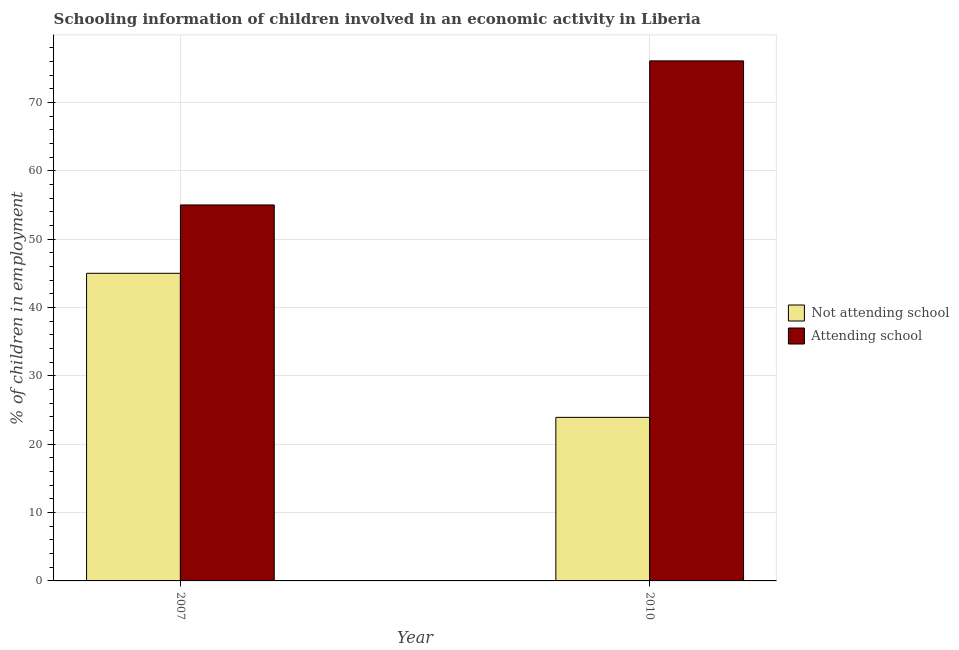How many different coloured bars are there?
Offer a terse response. 2. How many groups of bars are there?
Ensure brevity in your answer.  2. Are the number of bars per tick equal to the number of legend labels?
Offer a terse response. Yes. What is the label of the 2nd group of bars from the left?
Your answer should be very brief. 2010. What is the percentage of employed children who are attending school in 2007?
Offer a terse response. 55. Across all years, what is the maximum percentage of employed children who are attending school?
Your answer should be compact. 76.07. Across all years, what is the minimum percentage of employed children who are not attending school?
Ensure brevity in your answer.  23.93. In which year was the percentage of employed children who are attending school maximum?
Your response must be concise. 2010. In which year was the percentage of employed children who are not attending school minimum?
Give a very brief answer. 2010. What is the total percentage of employed children who are not attending school in the graph?
Provide a short and direct response. 68.93. What is the difference between the percentage of employed children who are attending school in 2007 and that in 2010?
Your answer should be compact. -21.07. What is the difference between the percentage of employed children who are attending school in 2010 and the percentage of employed children who are not attending school in 2007?
Your answer should be very brief. 21.07. What is the average percentage of employed children who are not attending school per year?
Provide a short and direct response. 34.46. In how many years, is the percentage of employed children who are not attending school greater than 58 %?
Give a very brief answer. 0. What is the ratio of the percentage of employed children who are attending school in 2007 to that in 2010?
Keep it short and to the point. 0.72. Is the percentage of employed children who are not attending school in 2007 less than that in 2010?
Your answer should be compact. No. In how many years, is the percentage of employed children who are not attending school greater than the average percentage of employed children who are not attending school taken over all years?
Your answer should be very brief. 1. What does the 2nd bar from the left in 2007 represents?
Offer a terse response. Attending school. What does the 1st bar from the right in 2007 represents?
Your response must be concise. Attending school. Are all the bars in the graph horizontal?
Offer a very short reply. No. What is the difference between two consecutive major ticks on the Y-axis?
Offer a terse response. 10. Does the graph contain grids?
Give a very brief answer. Yes. How many legend labels are there?
Make the answer very short. 2. What is the title of the graph?
Make the answer very short. Schooling information of children involved in an economic activity in Liberia. What is the label or title of the Y-axis?
Provide a succinct answer. % of children in employment. What is the % of children in employment in Not attending school in 2007?
Keep it short and to the point. 45. What is the % of children in employment of Not attending school in 2010?
Provide a short and direct response. 23.93. What is the % of children in employment in Attending school in 2010?
Offer a very short reply. 76.07. Across all years, what is the maximum % of children in employment of Attending school?
Provide a succinct answer. 76.07. Across all years, what is the minimum % of children in employment of Not attending school?
Provide a short and direct response. 23.93. What is the total % of children in employment in Not attending school in the graph?
Provide a succinct answer. 68.93. What is the total % of children in employment of Attending school in the graph?
Keep it short and to the point. 131.07. What is the difference between the % of children in employment of Not attending school in 2007 and that in 2010?
Provide a succinct answer. 21.07. What is the difference between the % of children in employment in Attending school in 2007 and that in 2010?
Provide a succinct answer. -21.07. What is the difference between the % of children in employment in Not attending school in 2007 and the % of children in employment in Attending school in 2010?
Give a very brief answer. -31.07. What is the average % of children in employment in Not attending school per year?
Keep it short and to the point. 34.46. What is the average % of children in employment in Attending school per year?
Provide a succinct answer. 65.54. In the year 2010, what is the difference between the % of children in employment in Not attending school and % of children in employment in Attending school?
Your response must be concise. -52.15. What is the ratio of the % of children in employment in Not attending school in 2007 to that in 2010?
Your response must be concise. 1.88. What is the ratio of the % of children in employment in Attending school in 2007 to that in 2010?
Your answer should be very brief. 0.72. What is the difference between the highest and the second highest % of children in employment of Not attending school?
Your answer should be very brief. 21.07. What is the difference between the highest and the second highest % of children in employment in Attending school?
Provide a short and direct response. 21.07. What is the difference between the highest and the lowest % of children in employment of Not attending school?
Provide a short and direct response. 21.07. What is the difference between the highest and the lowest % of children in employment in Attending school?
Provide a succinct answer. 21.07. 